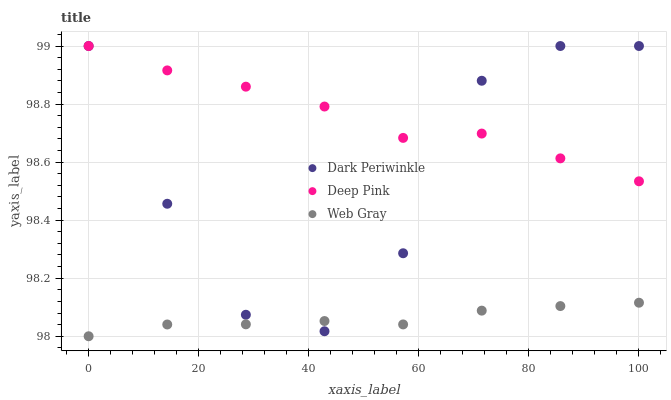Does Web Gray have the minimum area under the curve?
Answer yes or no. Yes. Does Deep Pink have the maximum area under the curve?
Answer yes or no. Yes. Does Dark Periwinkle have the minimum area under the curve?
Answer yes or no. No. Does Dark Periwinkle have the maximum area under the curve?
Answer yes or no. No. Is Web Gray the smoothest?
Answer yes or no. Yes. Is Dark Periwinkle the roughest?
Answer yes or no. Yes. Is Dark Periwinkle the smoothest?
Answer yes or no. No. Is Web Gray the roughest?
Answer yes or no. No. Does Web Gray have the lowest value?
Answer yes or no. Yes. Does Dark Periwinkle have the lowest value?
Answer yes or no. No. Does Dark Periwinkle have the highest value?
Answer yes or no. Yes. Does Web Gray have the highest value?
Answer yes or no. No. Is Web Gray less than Deep Pink?
Answer yes or no. Yes. Is Deep Pink greater than Web Gray?
Answer yes or no. Yes. Does Web Gray intersect Dark Periwinkle?
Answer yes or no. Yes. Is Web Gray less than Dark Periwinkle?
Answer yes or no. No. Is Web Gray greater than Dark Periwinkle?
Answer yes or no. No. Does Web Gray intersect Deep Pink?
Answer yes or no. No. 